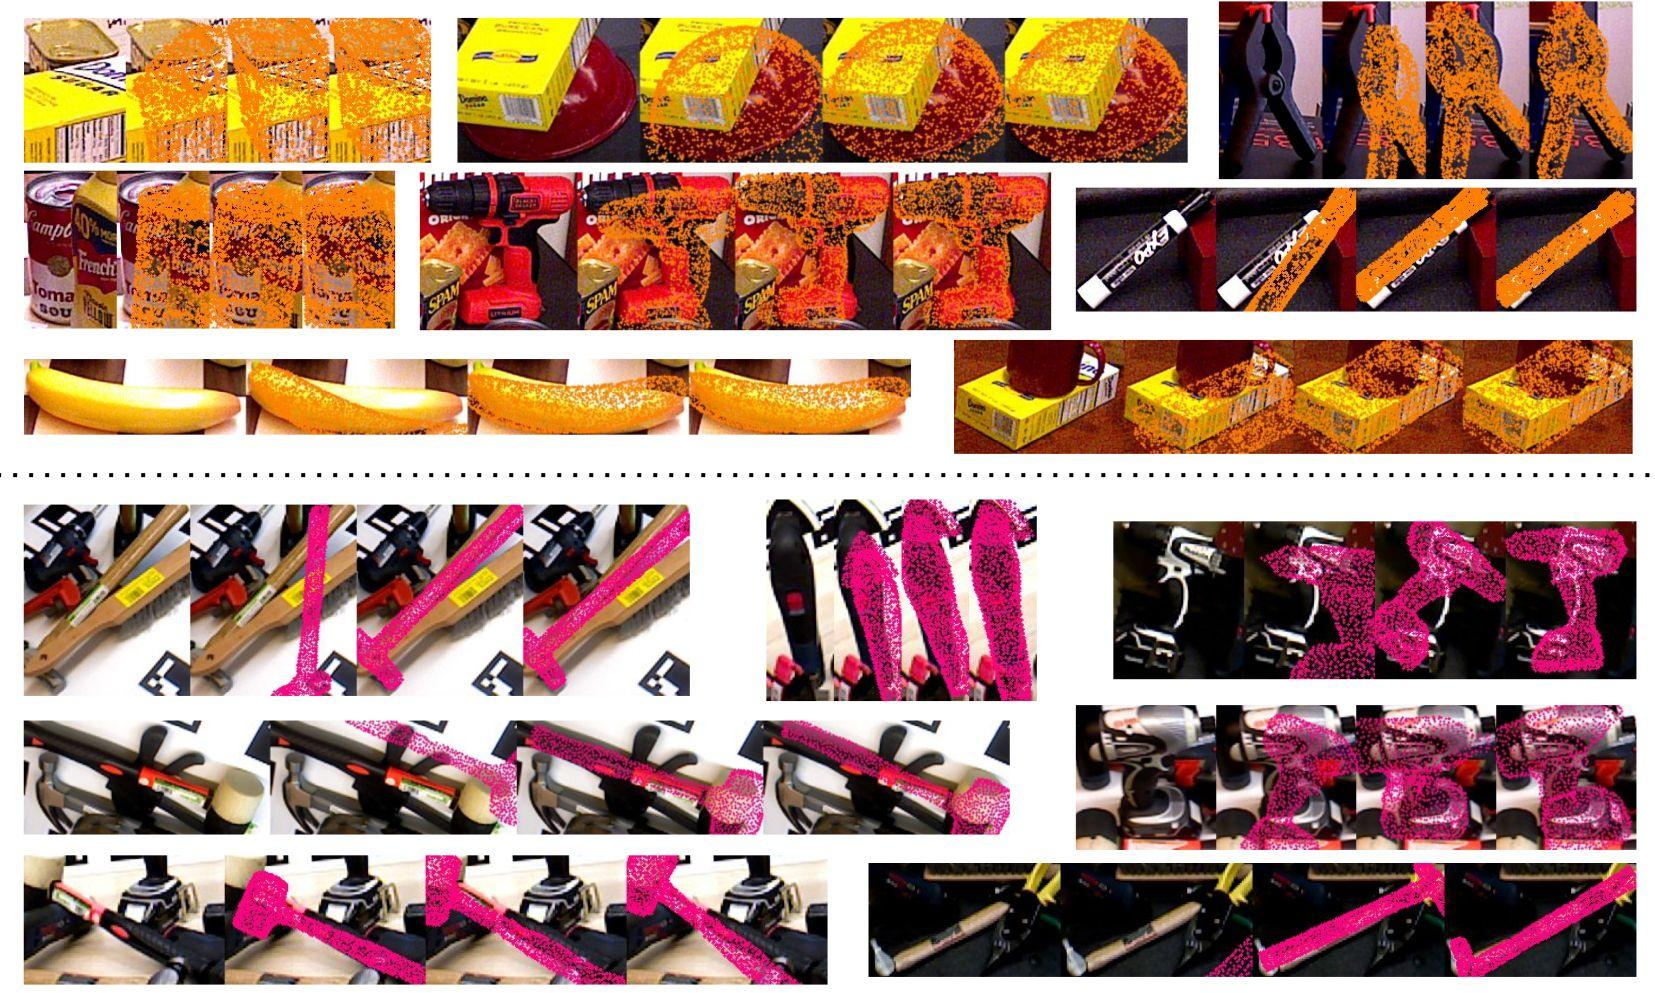Based on the disruption patterns observed, what is a common characteristic of the corruption applied across all rows? A) The corruption is applied more densely towards the center of the images. B) The corruption follows a horizontal strip pattern across the images. C) The disruption intensity is the same across all images. D) Each image within a row is corrupted with a different pattern. Each row of images shows a consistent pattern of horizontal strips where the corruption is applied, which becomes denser and more pronounced in each subsequent image. This pattern is consistent across all rows, distinguishing it from the other options which do not apply to every row of images. Therefore, the correct answer is B. 